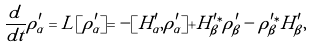Convert formula to latex. <formula><loc_0><loc_0><loc_500><loc_500>\frac { d } { d t } \rho _ { \alpha } ^ { \prime } = L [ \rho _ { \alpha } ^ { \prime } ] = - [ H _ { \alpha } ^ { \prime } , \rho _ { \alpha } ^ { \prime } ] + H _ { \beta } ^ { \prime \ast } \rho _ { \beta } ^ { \prime } - \rho _ { \beta } ^ { \prime \ast } H _ { \beta } ^ { \prime } ,</formula> 